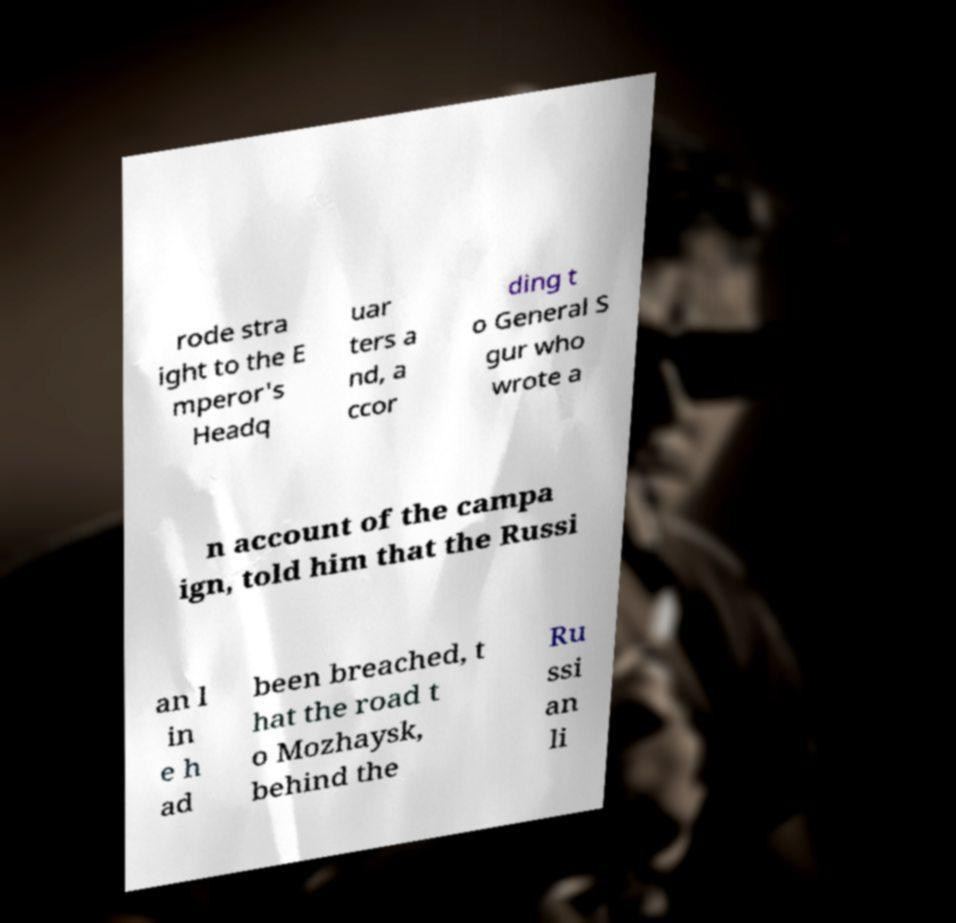Please identify and transcribe the text found in this image. rode stra ight to the E mperor's Headq uar ters a nd, a ccor ding t o General S gur who wrote a n account of the campa ign, told him that the Russi an l in e h ad been breached, t hat the road t o Mozhaysk, behind the Ru ssi an li 